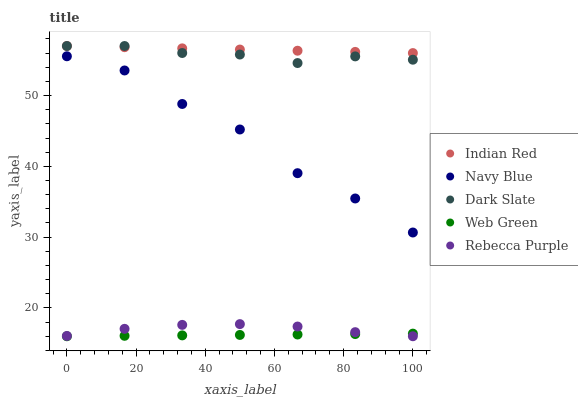Does Web Green have the minimum area under the curve?
Answer yes or no. Yes. Does Indian Red have the maximum area under the curve?
Answer yes or no. Yes. Does Rebecca Purple have the minimum area under the curve?
Answer yes or no. No. Does Rebecca Purple have the maximum area under the curve?
Answer yes or no. No. Is Web Green the smoothest?
Answer yes or no. Yes. Is Navy Blue the roughest?
Answer yes or no. Yes. Is Rebecca Purple the smoothest?
Answer yes or no. No. Is Rebecca Purple the roughest?
Answer yes or no. No. Does Rebecca Purple have the lowest value?
Answer yes or no. Yes. Does Indian Red have the lowest value?
Answer yes or no. No. Does Dark Slate have the highest value?
Answer yes or no. Yes. Does Rebecca Purple have the highest value?
Answer yes or no. No. Is Web Green less than Dark Slate?
Answer yes or no. Yes. Is Indian Red greater than Navy Blue?
Answer yes or no. Yes. Does Indian Red intersect Dark Slate?
Answer yes or no. Yes. Is Indian Red less than Dark Slate?
Answer yes or no. No. Is Indian Red greater than Dark Slate?
Answer yes or no. No. Does Web Green intersect Dark Slate?
Answer yes or no. No. 